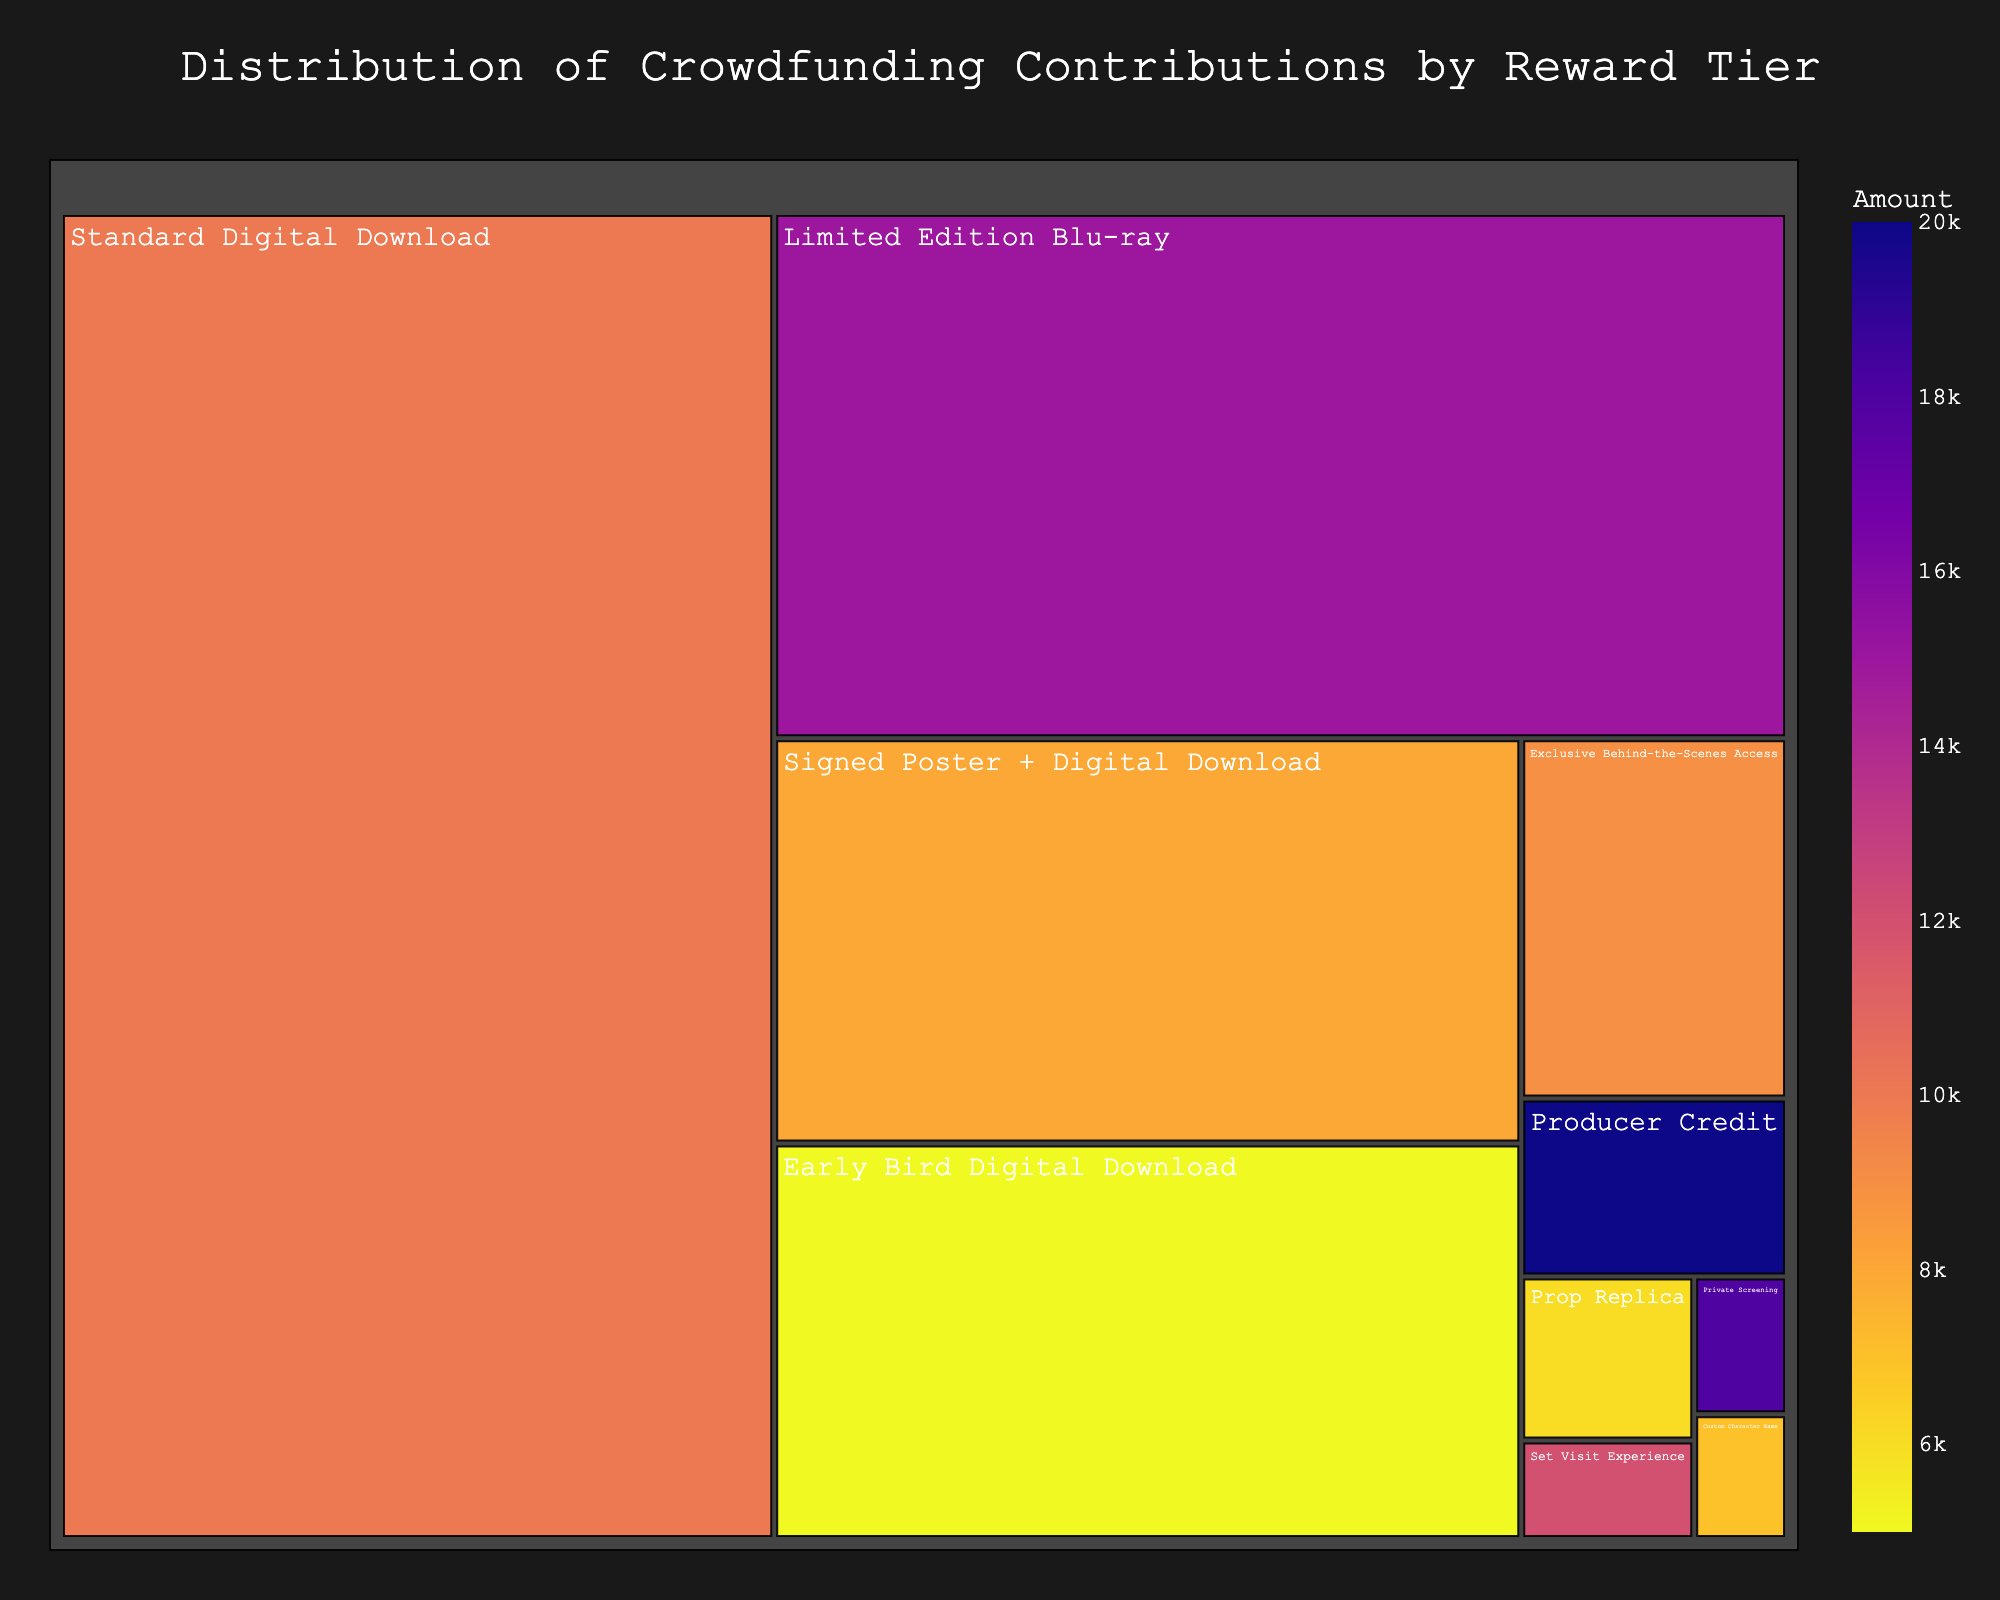What is the title of the figure? The title is displayed at the top of the figure, centered and highlighted in a larger font. It gives an insight into what the figure represents.
Answer: Distribution of Crowdfunding Contributions by Reward Tier Which reward tier has the most contributions in total amount? The total contributions for each reward tier are represented by the size of its section in the treemap. The section labeled "Producer Credit" is the largest.
Answer: Producer Credit How many backers contributed to the 'Standard Digital Download' tier? Hovering over the 'Standard Digital Download' section reveals a tooltip showing the number of backers.
Answer: 400 Which tier has the fewest number of backers? The smallest section in the treemap reflects the tier with the fewest backers. The tooltip can confirm the exact number.
Answer: Private Screening What is the total amount raised by the 'Limited Edition Blu-ray' rewards tier? The tooltip for 'Limited Edition Blu-ray' shows both the number of backers and the amount per backer. Multiplying these will give the total contribution amount.
Answer: $2,250,000 Compare the contributions from 'Set Visit Experience' and 'Custom Character Name'. Which one is higher? Observing and comparing the areas of these sections in the treemap and confirming via the hover tooltips reveal that 'Set Visit Experience' has a higher total contribution.
Answer: Set Visit Experience What is the total amount raised by tiers with fewer than 50 backers? Identify the sections in the treemap representing tiers with fewer than 50 backers and sum their total contributions: 'Producer Credit', 'Set Visit Experience', 'Private Screening', 'Custom Character Name', and 'Prop Replica'.
Answer: $580,000 Which reward tier has a similar number of backers as 'Prop Replica'? Hover over different sections to find another tier with approximately 20 backers, like 'Exclusive Behind-the-Scenes Access' which has 45 backers, close to another subset 'Signed Poster + Digital Download' with 160 backers although it's not similar but a single/more backers data subset.
Answer: No exact match to Prop Replica (closest: Exclusive Behind-the-Scenes Access with different wide range) Are contributions for 'Signed Poster + Digital Download' higher or lower than 'Limited Edition Blu-ray'? By comparing the areas of the respective sections and checking the values detailed in their tooltips, 'Signed Poster + Digital Download' has less total contributions.
Answer: Lower Which reward tier raised more funds: 'Exclusive Behind-the-Scenes Access' or 'Standard Digital Download'? Compare the areas of the sections for 'Exclusive Behind-the-Scenes Access' and 'Standard Digital Download' and verify the values in the tooltips. 'Standard Digital Download' has more total funds raised.
Answer: Standard Digital Download 